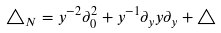<formula> <loc_0><loc_0><loc_500><loc_500>\triangle _ { N } = y ^ { - 2 } \partial _ { 0 } ^ { 2 } + y ^ { - 1 } \partial _ { y } y \partial _ { y } + \triangle</formula> 